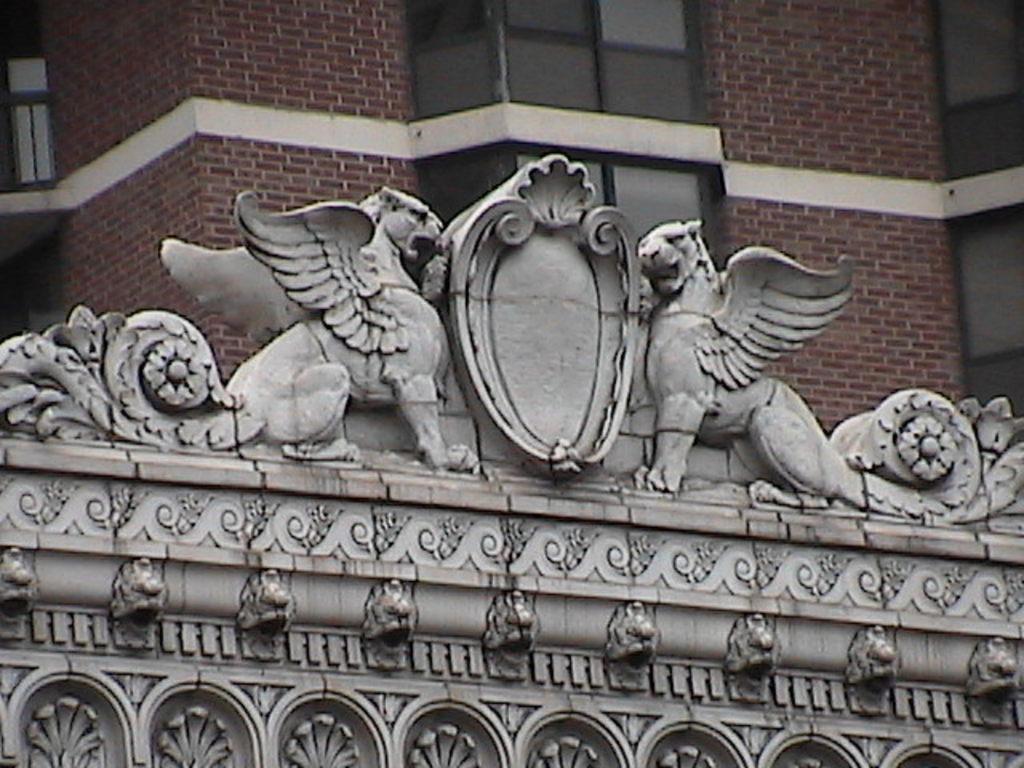Please provide a concise description of this image. In this picture we can see the stone carving and behind the stone carving there is a building with windows. 